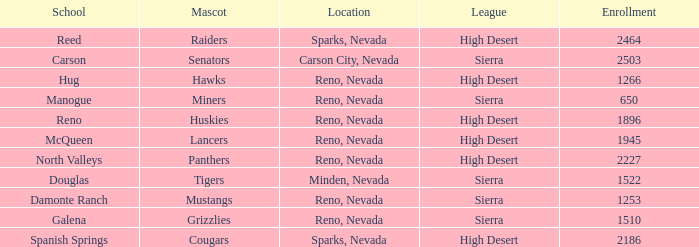What city and state are the miners located in? Reno, Nevada. 